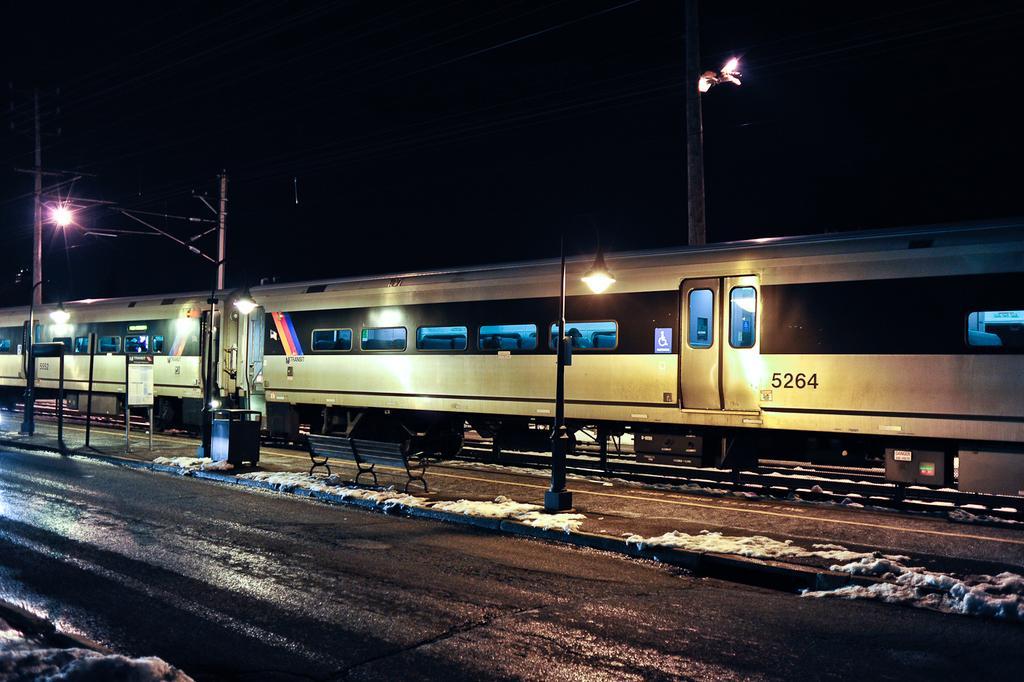How would you summarize this image in a sentence or two? This image is taken during night mode. In this image there is a train, poles. We can also see road and also bench. 